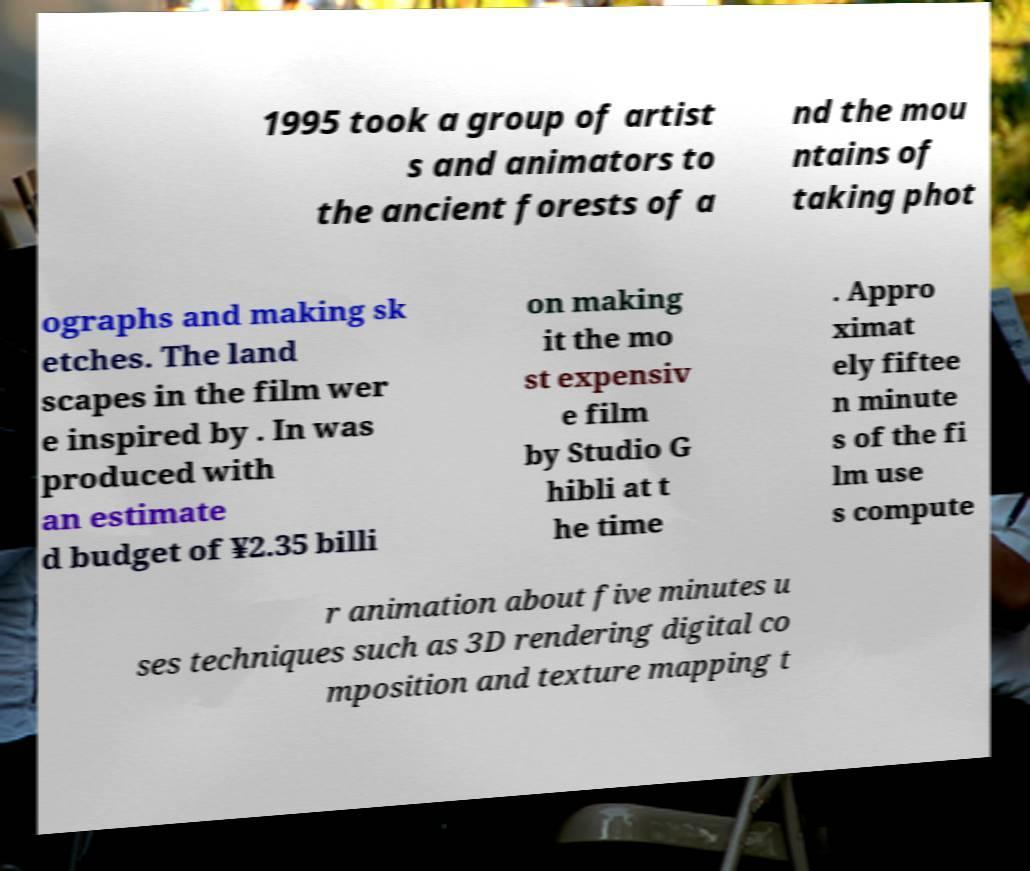What messages or text are displayed in this image? I need them in a readable, typed format. 1995 took a group of artist s and animators to the ancient forests of a nd the mou ntains of taking phot ographs and making sk etches. The land scapes in the film wer e inspired by . In was produced with an estimate d budget of ¥2.35 billi on making it the mo st expensiv e film by Studio G hibli at t he time . Appro ximat ely fiftee n minute s of the fi lm use s compute r animation about five minutes u ses techniques such as 3D rendering digital co mposition and texture mapping t 